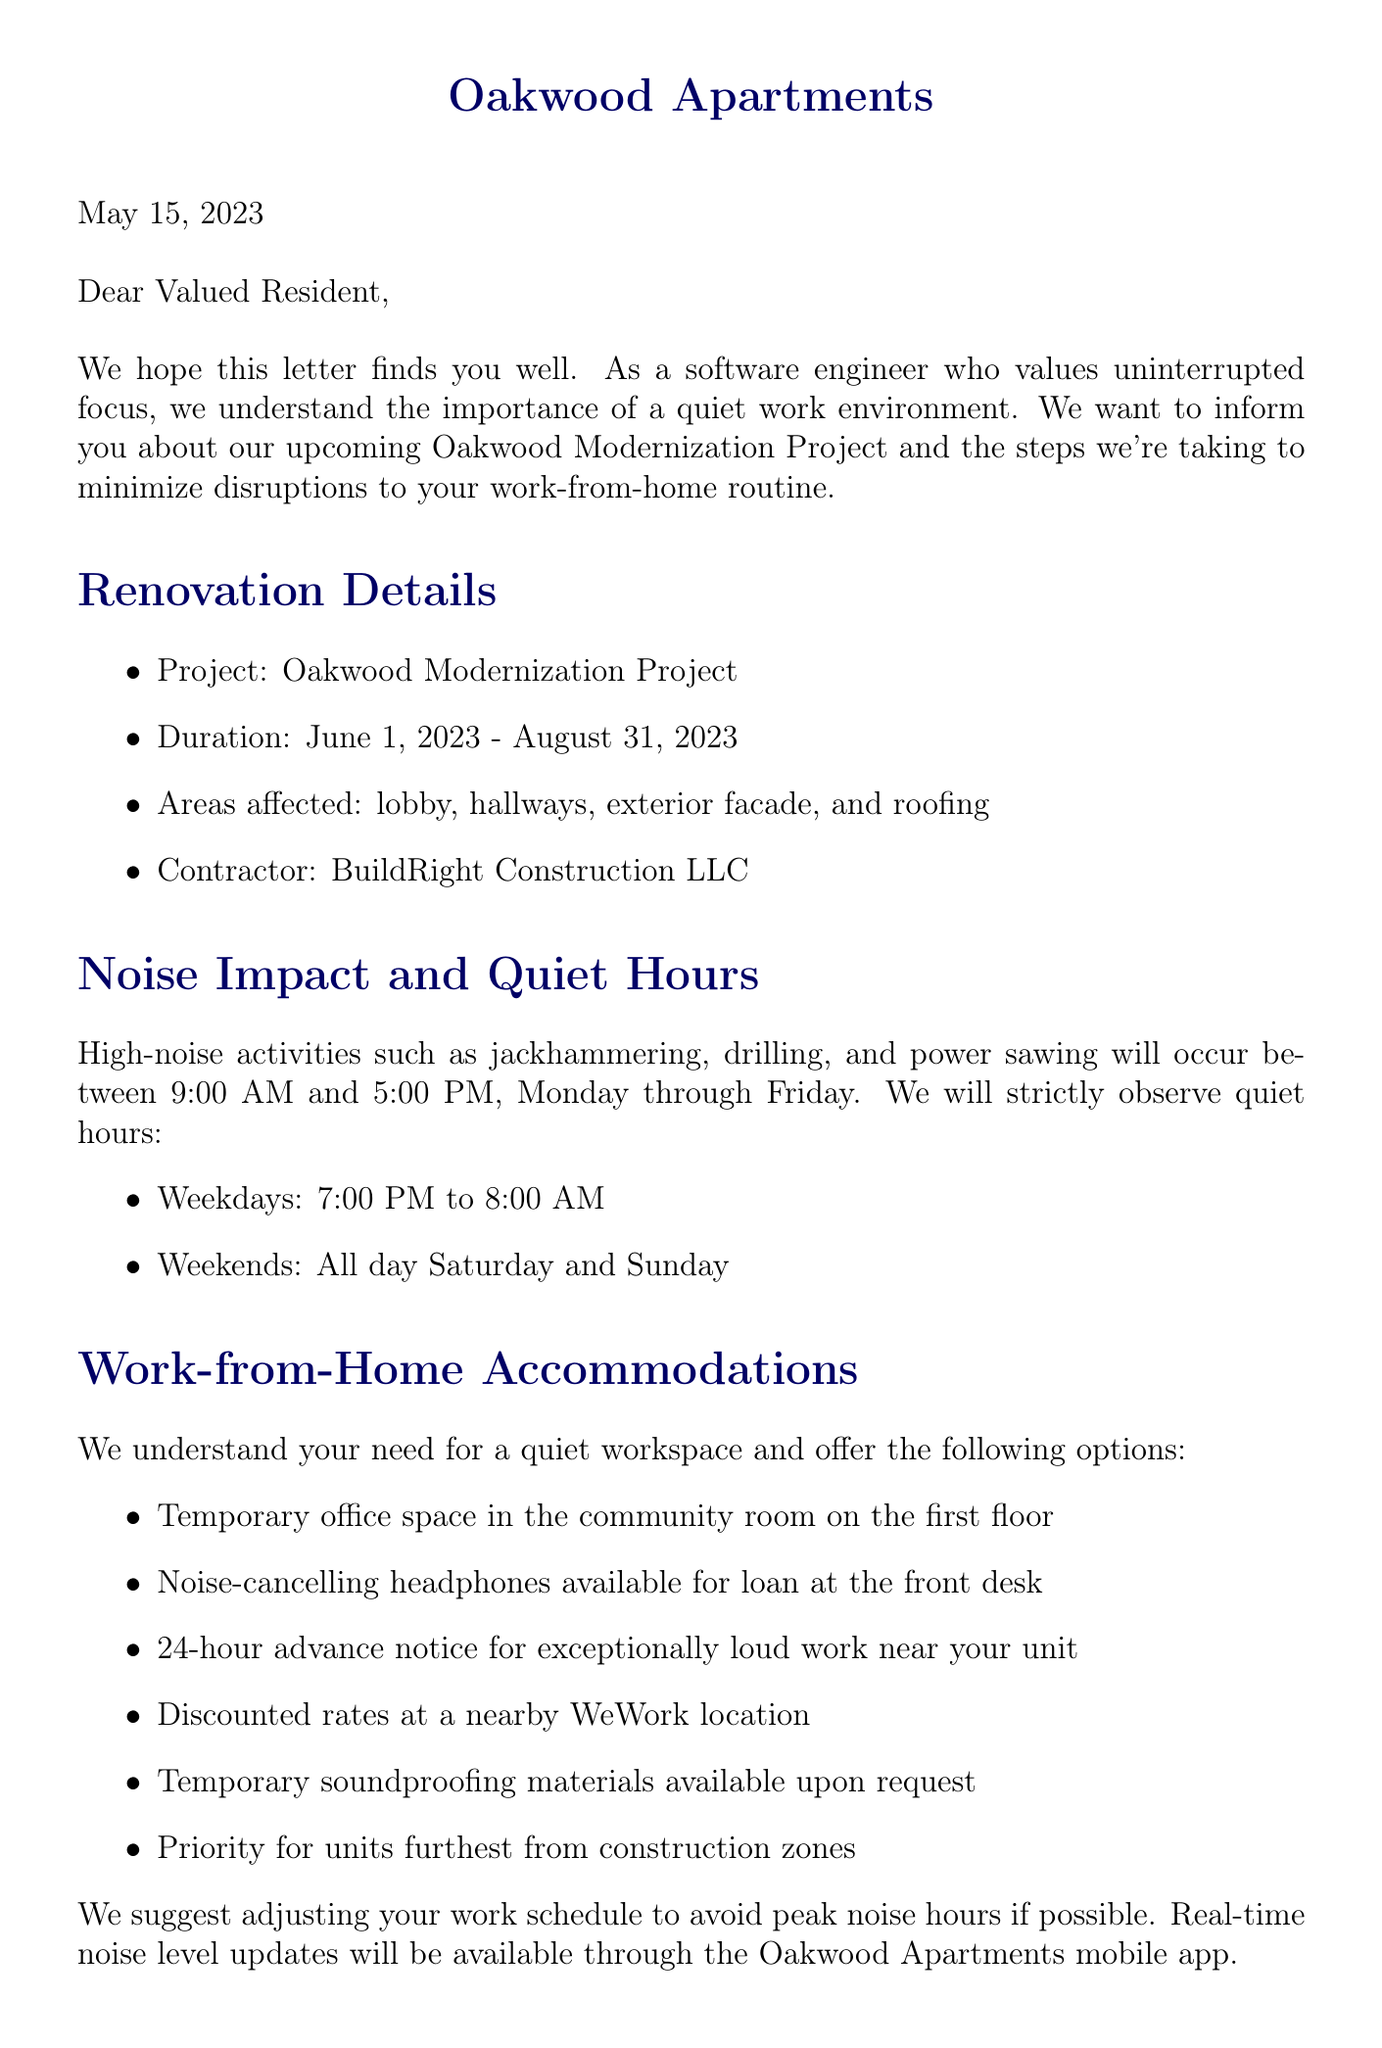What is the project name? The project name is explicitly mentioned in the renovations section of the document.
Answer: Oakwood Modernization Project When does the renovation start? The start date of the renovation is provided clearly in the timeline.
Answer: June 1, 2023 What hours are designated for noisy activities? The document specifies the expected hours for high-noise activities.
Answer: 9:00 AM to 5:00 PM What compensation is offered for the inconvenience? The document lists specific compensation options for residents.
Answer: 10% discount for June, July, and August Who is the property manager? The contact information section identifies the property manager by name.
Answer: Sarah Johnson What days of the week will the construction work occur? The document clearly outlines the days when work will be conducted.
Answer: Monday through Friday What options are available for work-from-home accommodations? The work-from-home accommodations section lists available options.
Answer: Temporary office space, noise-cancelling headphones How can residents receive real-time noise updates? The document mentions a specific method for monitoring noise levels.
Answer: Oakwood Apartments mobile app 